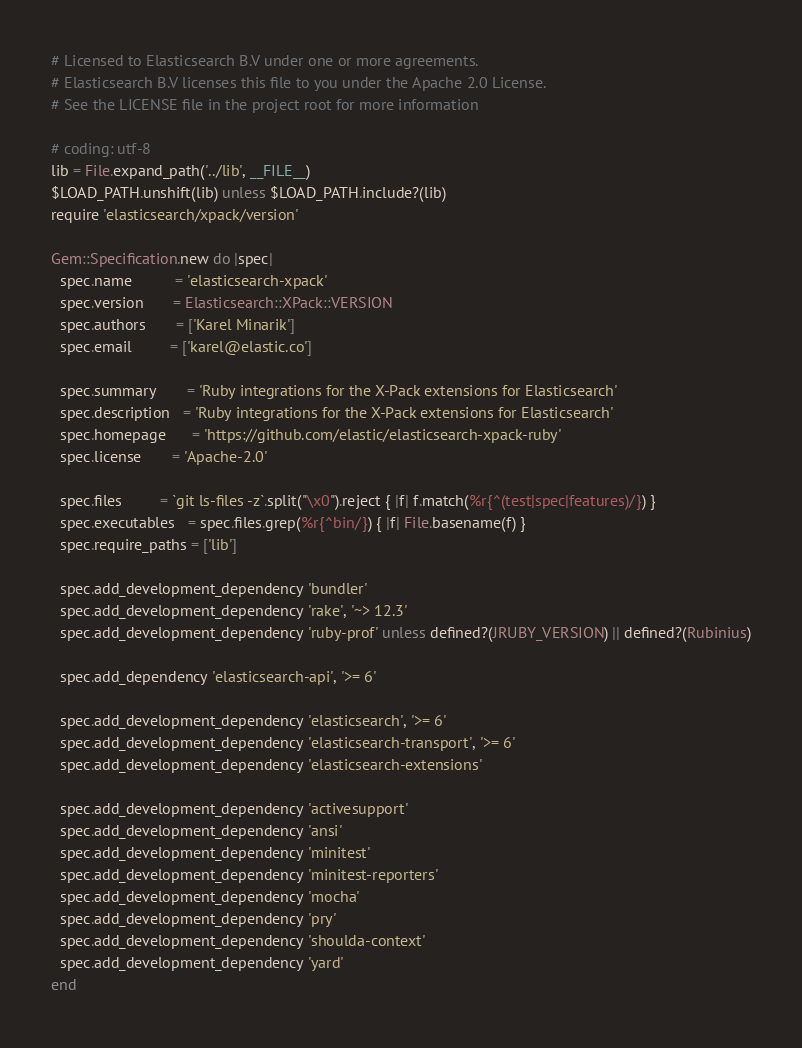<code> <loc_0><loc_0><loc_500><loc_500><_Ruby_># Licensed to Elasticsearch B.V under one or more agreements.
# Elasticsearch B.V licenses this file to you under the Apache 2.0 License.
# See the LICENSE file in the project root for more information

# coding: utf-8
lib = File.expand_path('../lib', __FILE__)
$LOAD_PATH.unshift(lib) unless $LOAD_PATH.include?(lib)
require 'elasticsearch/xpack/version'

Gem::Specification.new do |spec|
  spec.name          = 'elasticsearch-xpack'
  spec.version       = Elasticsearch::XPack::VERSION
  spec.authors       = ['Karel Minarik']
  spec.email         = ['karel@elastic.co']

  spec.summary       = 'Ruby integrations for the X-Pack extensions for Elasticsearch'
  spec.description   = 'Ruby integrations for the X-Pack extensions for Elasticsearch'
  spec.homepage      = 'https://github.com/elastic/elasticsearch-xpack-ruby'
  spec.license       = 'Apache-2.0'

  spec.files         = `git ls-files -z`.split("\x0").reject { |f| f.match(%r{^(test|spec|features)/}) }
  spec.executables   = spec.files.grep(%r{^bin/}) { |f| File.basename(f) }
  spec.require_paths = ['lib']

  spec.add_development_dependency 'bundler'
  spec.add_development_dependency 'rake', '~> 12.3'
  spec.add_development_dependency 'ruby-prof' unless defined?(JRUBY_VERSION) || defined?(Rubinius)

  spec.add_dependency 'elasticsearch-api', '>= 6'

  spec.add_development_dependency 'elasticsearch', '>= 6'
  spec.add_development_dependency 'elasticsearch-transport', '>= 6'
  spec.add_development_dependency 'elasticsearch-extensions'

  spec.add_development_dependency 'activesupport'
  spec.add_development_dependency 'ansi'
  spec.add_development_dependency 'minitest'
  spec.add_development_dependency 'minitest-reporters'
  spec.add_development_dependency 'mocha'
  spec.add_development_dependency 'pry'
  spec.add_development_dependency 'shoulda-context'
  spec.add_development_dependency 'yard'
end
</code> 